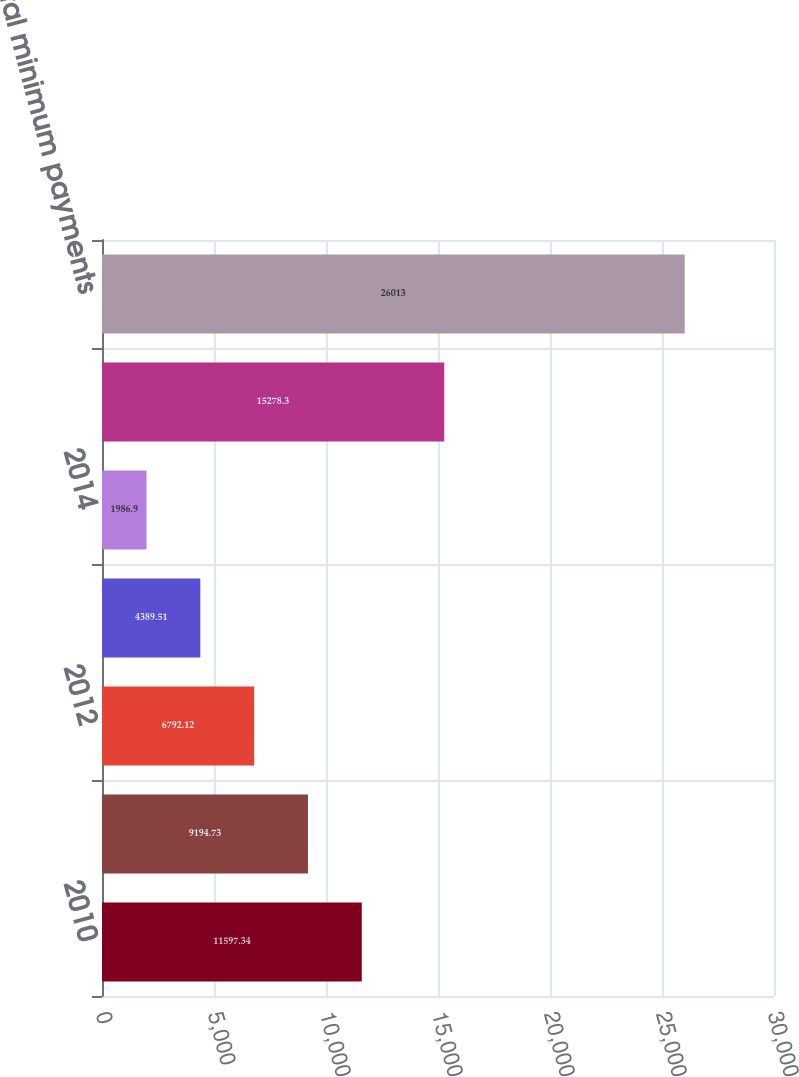<chart> <loc_0><loc_0><loc_500><loc_500><bar_chart><fcel>2010<fcel>2011<fcel>2012<fcel>2013<fcel>2014<fcel>Thereafter<fcel>Total minimum payments<nl><fcel>11597.3<fcel>9194.73<fcel>6792.12<fcel>4389.51<fcel>1986.9<fcel>15278.3<fcel>26013<nl></chart> 